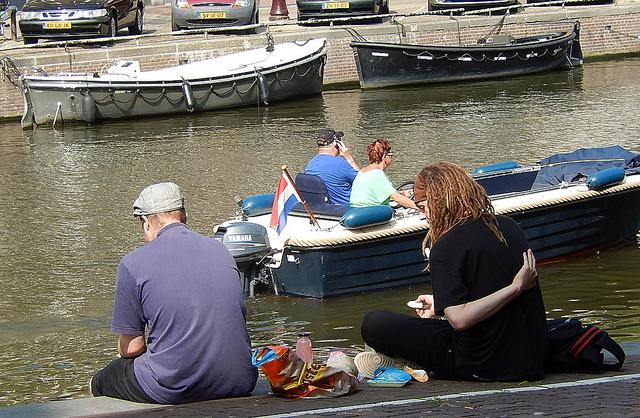A small vessel for travelling over water propelled by oars sails or an engine is?

Choices:
A) flight
B) boat
C) ship
D) floater boat 